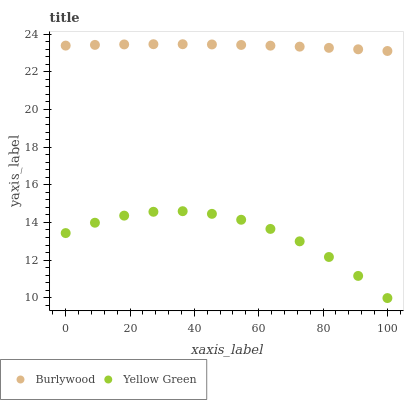Does Yellow Green have the minimum area under the curve?
Answer yes or no. Yes. Does Burlywood have the maximum area under the curve?
Answer yes or no. Yes. Does Yellow Green have the maximum area under the curve?
Answer yes or no. No. Is Burlywood the smoothest?
Answer yes or no. Yes. Is Yellow Green the roughest?
Answer yes or no. Yes. Is Yellow Green the smoothest?
Answer yes or no. No. Does Yellow Green have the lowest value?
Answer yes or no. Yes. Does Burlywood have the highest value?
Answer yes or no. Yes. Does Yellow Green have the highest value?
Answer yes or no. No. Is Yellow Green less than Burlywood?
Answer yes or no. Yes. Is Burlywood greater than Yellow Green?
Answer yes or no. Yes. Does Yellow Green intersect Burlywood?
Answer yes or no. No. 